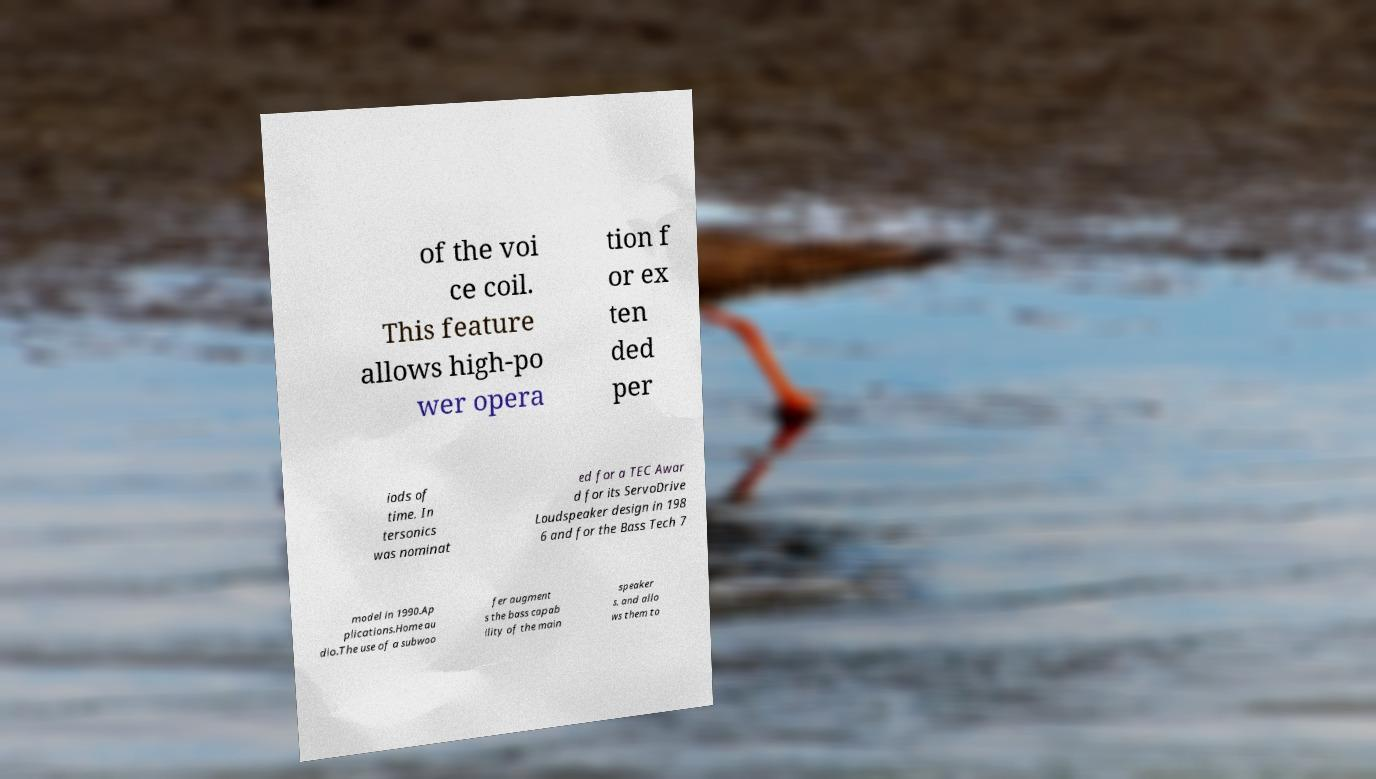There's text embedded in this image that I need extracted. Can you transcribe it verbatim? of the voi ce coil. This feature allows high-po wer opera tion f or ex ten ded per iods of time. In tersonics was nominat ed for a TEC Awar d for its ServoDrive Loudspeaker design in 198 6 and for the Bass Tech 7 model in 1990.Ap plications.Home au dio.The use of a subwoo fer augment s the bass capab ility of the main speaker s, and allo ws them to 